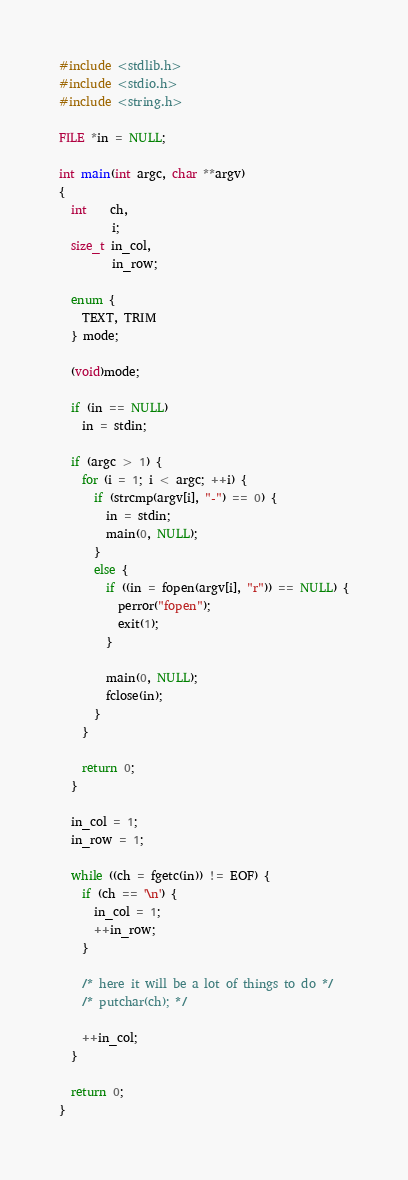Convert code to text. <code><loc_0><loc_0><loc_500><loc_500><_C_>#include <stdlib.h>
#include <stdio.h>
#include <string.h>

FILE *in = NULL;

int main(int argc, char **argv)
{
  int    ch,
         i;
  size_t in_col,
         in_row;

  enum {
    TEXT, TRIM
  } mode;

  (void)mode;

  if (in == NULL)
    in = stdin; 

  if (argc > 1) {
    for (i = 1; i < argc; ++i) {
      if (strcmp(argv[i], "-") == 0) {
        in = stdin;
        main(0, NULL);
      }
      else {
        if ((in = fopen(argv[i], "r")) == NULL) {
          perror("fopen");
          exit(1);
        }

        main(0, NULL);
        fclose(in);
      }
    }

    return 0;
  }

  in_col = 1;
  in_row = 1;

  while ((ch = fgetc(in)) != EOF) {
    if (ch == '\n') {
      in_col = 1;
      ++in_row;
    }

    /* here it will be a lot of things to do */
    /* putchar(ch); */

    ++in_col;
  }

  return 0;
}
</code> 